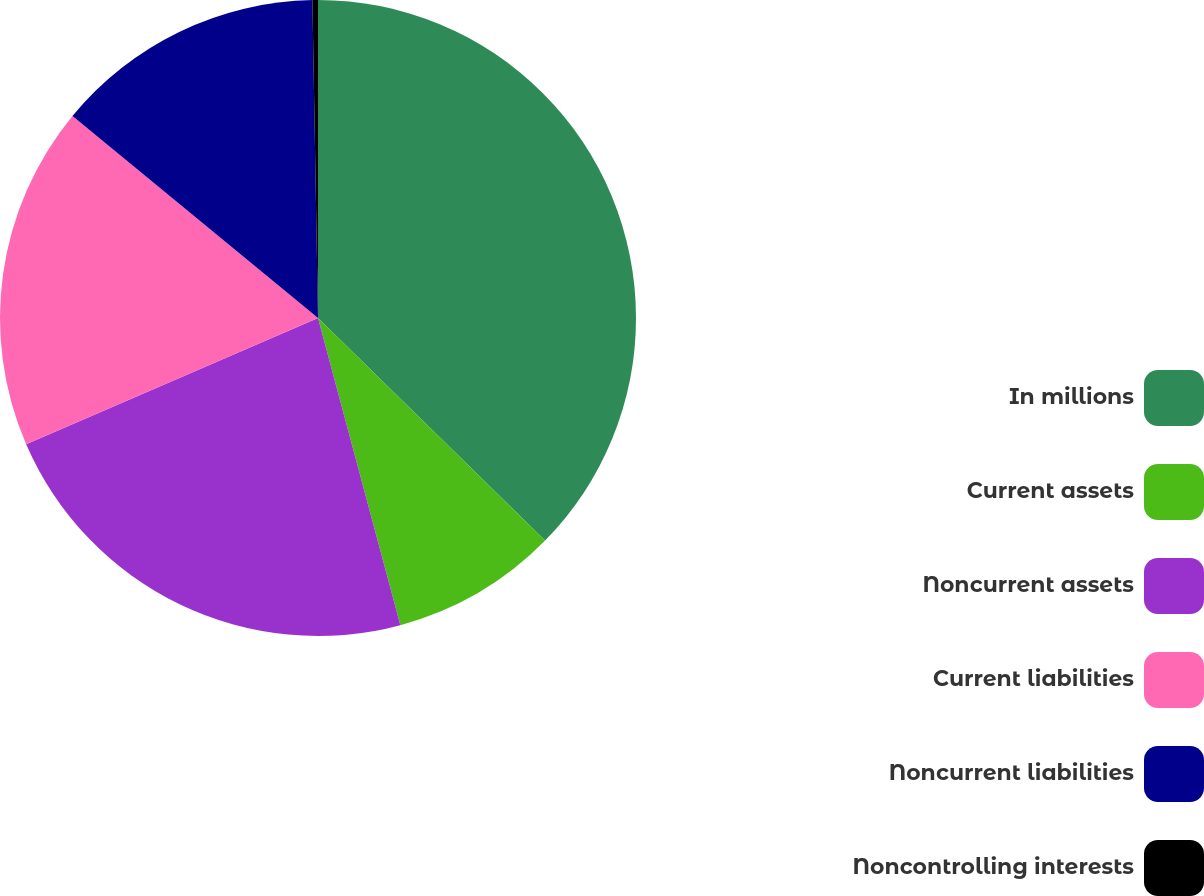Convert chart to OTSL. <chart><loc_0><loc_0><loc_500><loc_500><pie_chart><fcel>In millions<fcel>Current assets<fcel>Noncurrent assets<fcel>Current liabilities<fcel>Noncurrent liabilities<fcel>Noncontrolling interests<nl><fcel>37.34%<fcel>8.49%<fcel>22.67%<fcel>17.46%<fcel>13.76%<fcel>0.28%<nl></chart> 